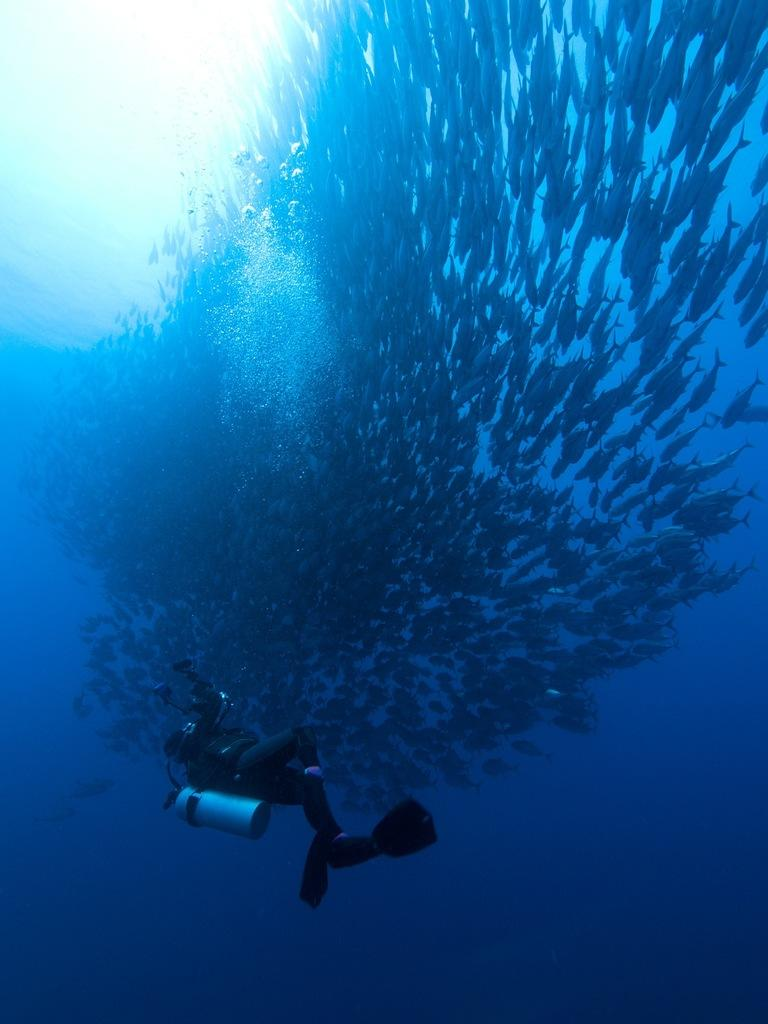What type of environment is shown in the image? The image depicts an underwater environment. What is the person in the image doing? There is a person swimming in the water. What other living creatures can be seen in the image? Fishes are present in the image. What object is the person carrying while swimming? The person is carrying a cylinder. What type of machine can be seen in the background of the image? There is no machine present in the image; it depicts an underwater environment with a person swimming and fishes. 